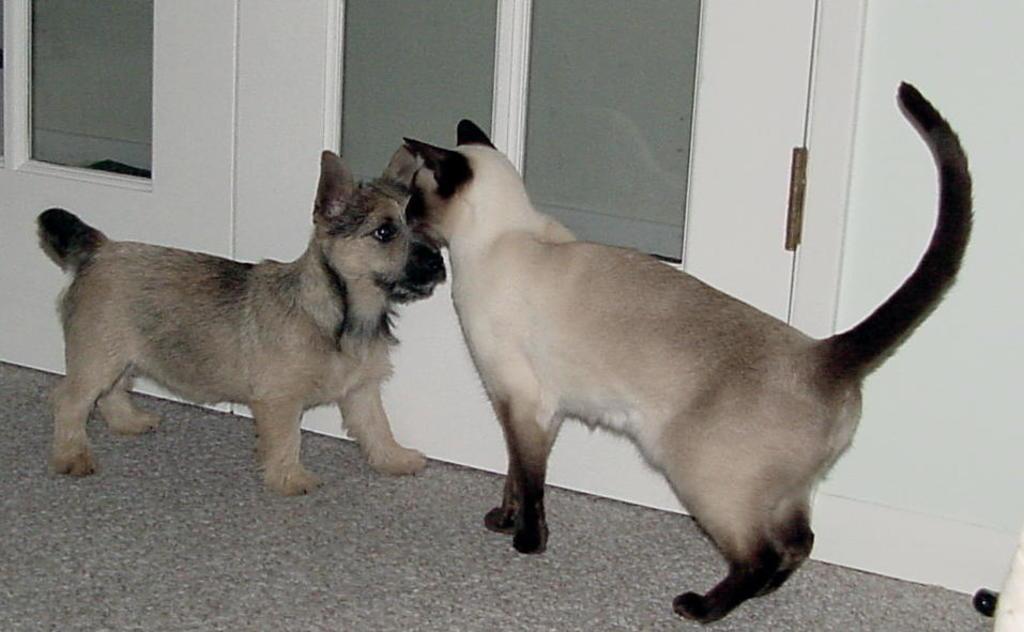Describe this image in one or two sentences. As we can see in the image there is a white color wall, doors, cat and a dog. 